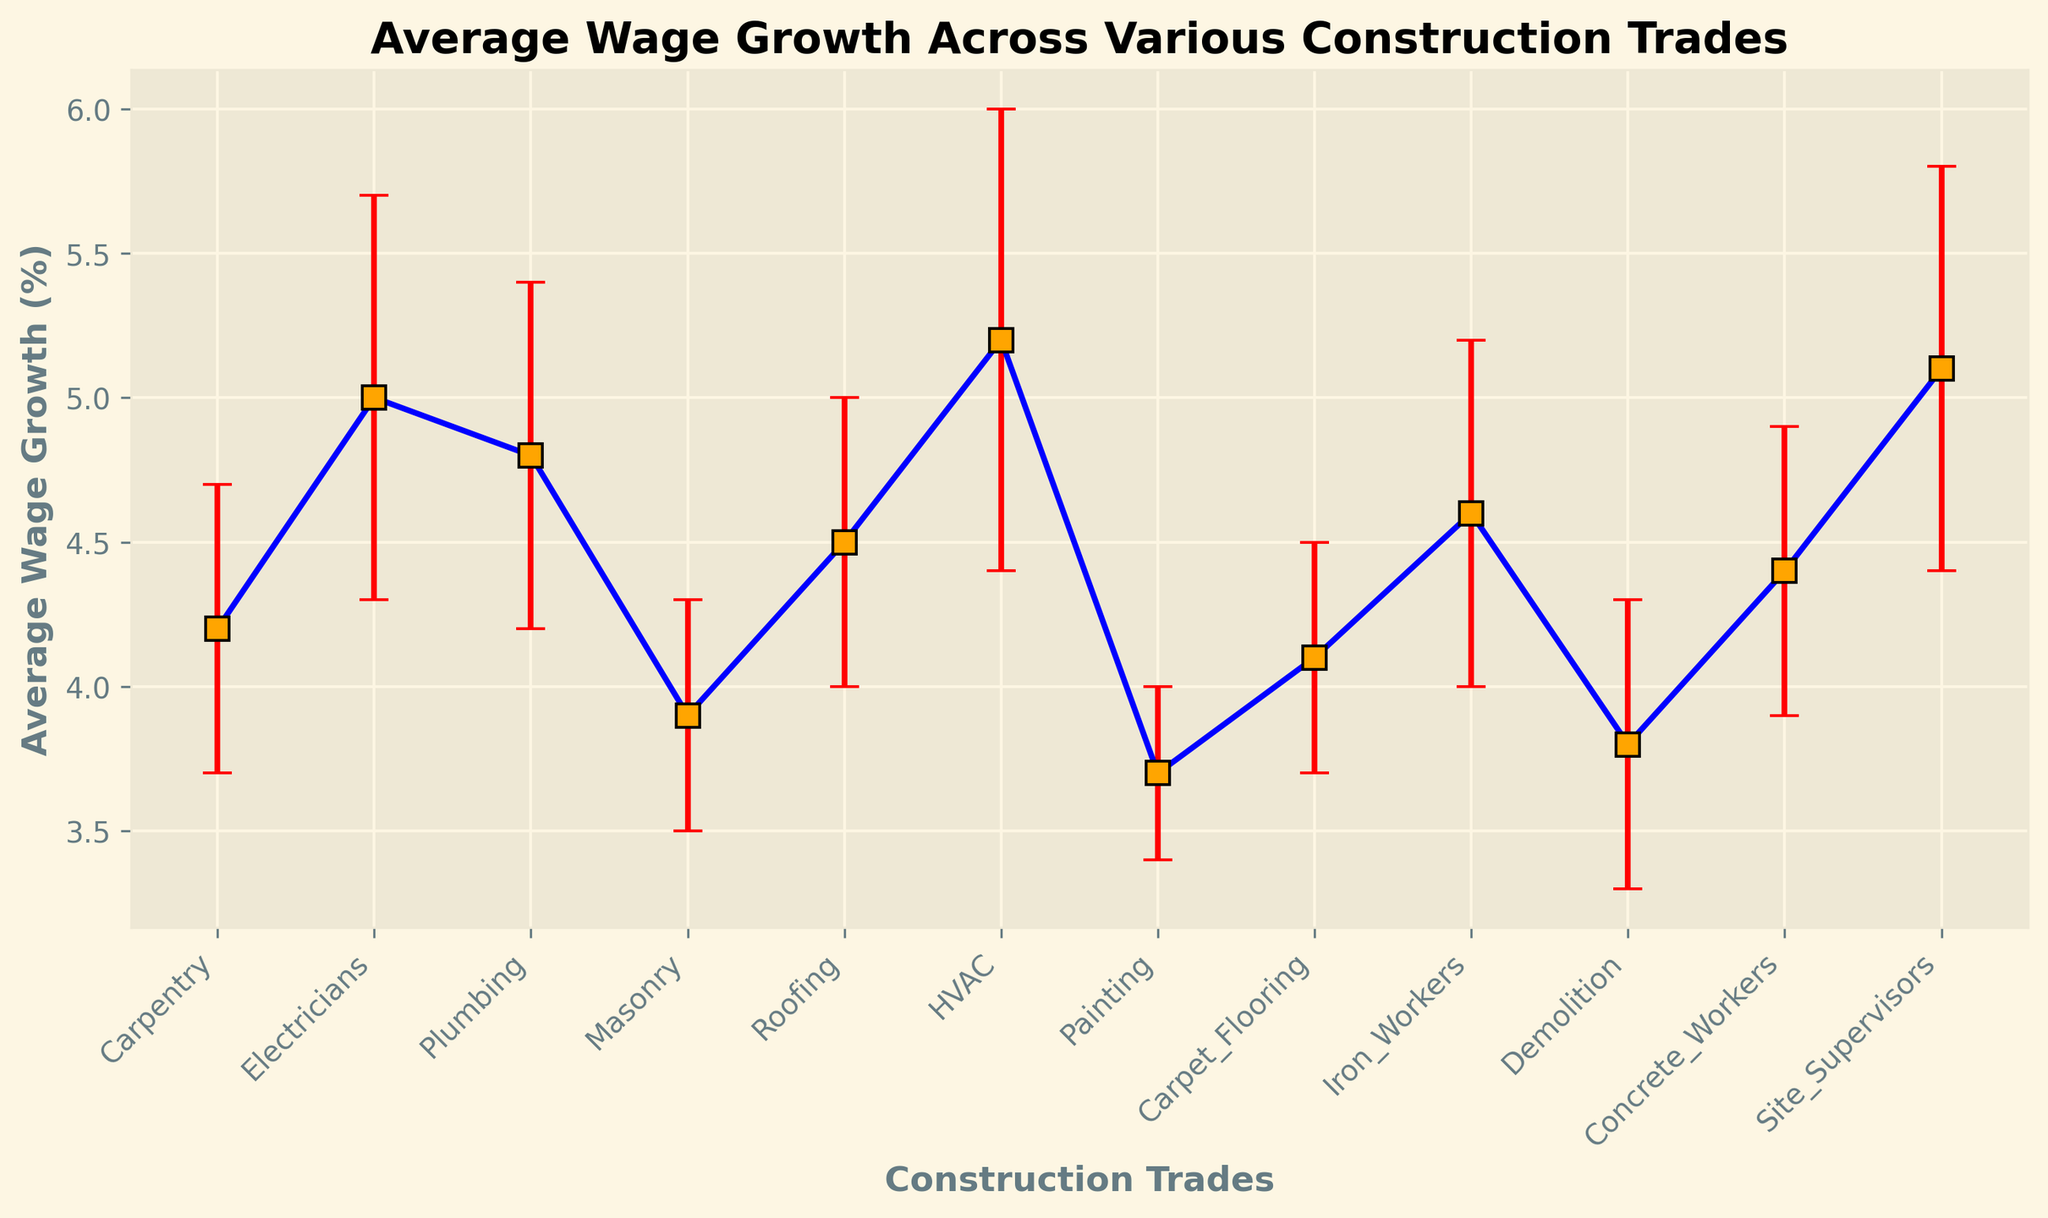What trade has the highest average wage growth? Looking at the y-values (average wage growth) in the figure, the trade with the highest marker will indicate the highest growth. HVAC has the highest point.
Answer: HVAC What is the average wage growth across all trades? Sum all the average wage growth values and then divide by the number of trades. (4.2 + 5.0 + 4.8 + 3.9 + 4.5 + 5.2 + 3.7 + 4.1 + 4.6 + 3.8 + 4.4 + 5.1) / 12 = 53.3 / 12 ≈ 4.44
Answer: 4.44 Which trade has the smallest regional difference error? The shortest error bar indicates the smallest regional difference. Painting has the shortest error bar (0.3).
Answer: Painting Compare the average wage growth of Electricians and Plumbers. Which one is higher? Electricians have an average wage growth of 5.0%, and Plumbing has 4.8%. 5.0 is greater than 4.8.
Answer: Electricians What is the sum of the average wage growth for Roofing and Site Supervisors? Add the average wage growth of Roofing (4.5) and Site Supervisors (5.1). 4.5 + 5.1 = 9.6
Answer: 9.6 Which trades have an average wage growth over 5%? Check visually for markers exceeding the 5% line. Electricians (5.0), HVAC (5.2), and Site Supervisors (5.1) are over 5%.
Answer: Electricians, HVAC, Site Supervisors How does the error bar of HVAC compare to that of Carpentry? Visually compare the length of the error bars; HVAC has a longer error bar (0.8) than Carpentry (0.5).
Answer: Longer What is the difference in average wage growth between Masonry and Iron Workers? Subtract the average wage growth of Masonry (3.9) from Iron Workers (4.6). 4.6 - 3.9 = 0.7
Answer: 0.7 